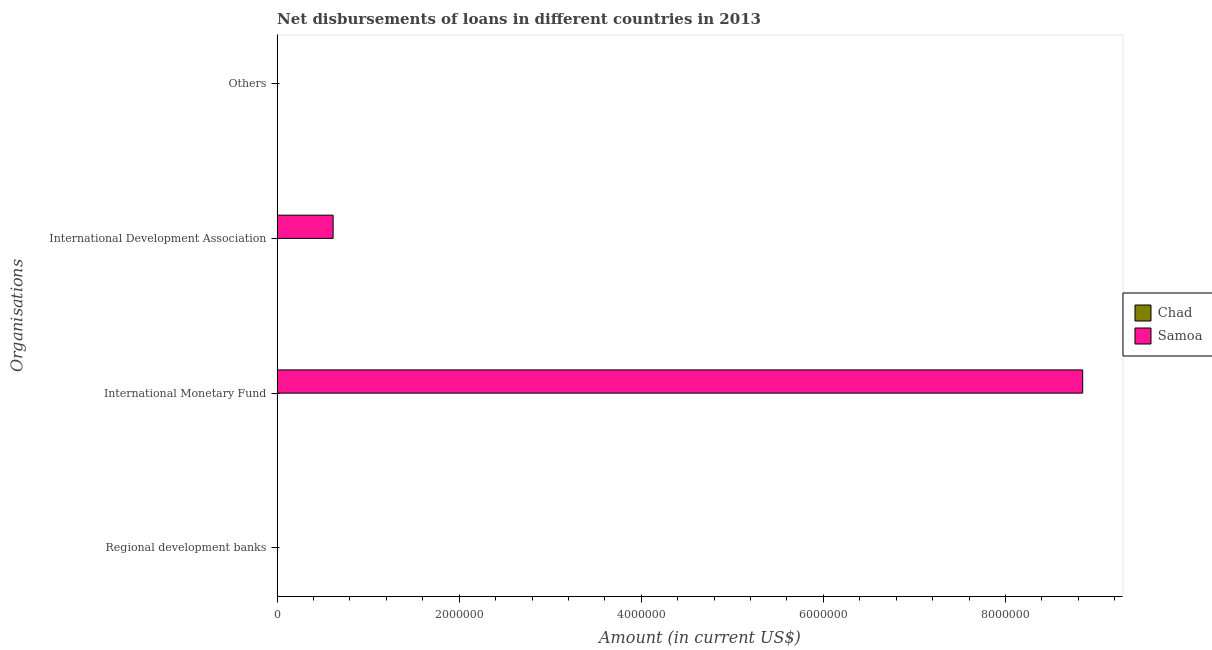How many different coloured bars are there?
Your answer should be compact. 1. Are the number of bars on each tick of the Y-axis equal?
Provide a short and direct response. No. What is the label of the 2nd group of bars from the top?
Keep it short and to the point. International Development Association. What is the amount of loan disimbursed by international monetary fund in Samoa?
Offer a very short reply. 8.85e+06. Across all countries, what is the maximum amount of loan disimbursed by international development association?
Give a very brief answer. 6.15e+05. In which country was the amount of loan disimbursed by international monetary fund maximum?
Keep it short and to the point. Samoa. What is the average amount of loan disimbursed by international monetary fund per country?
Keep it short and to the point. 4.42e+06. What is the difference between the highest and the lowest amount of loan disimbursed by international development association?
Your response must be concise. 6.15e+05. Is it the case that in every country, the sum of the amount of loan disimbursed by international monetary fund and amount of loan disimbursed by regional development banks is greater than the sum of amount of loan disimbursed by international development association and amount of loan disimbursed by other organisations?
Your response must be concise. No. Are all the bars in the graph horizontal?
Offer a very short reply. Yes. How many countries are there in the graph?
Offer a very short reply. 2. Are the values on the major ticks of X-axis written in scientific E-notation?
Provide a succinct answer. No. Does the graph contain any zero values?
Give a very brief answer. Yes. Does the graph contain grids?
Make the answer very short. No. How many legend labels are there?
Offer a very short reply. 2. How are the legend labels stacked?
Keep it short and to the point. Vertical. What is the title of the graph?
Provide a short and direct response. Net disbursements of loans in different countries in 2013. Does "Trinidad and Tobago" appear as one of the legend labels in the graph?
Give a very brief answer. No. What is the label or title of the X-axis?
Provide a succinct answer. Amount (in current US$). What is the label or title of the Y-axis?
Provide a succinct answer. Organisations. What is the Amount (in current US$) in Samoa in International Monetary Fund?
Your response must be concise. 8.85e+06. What is the Amount (in current US$) in Samoa in International Development Association?
Keep it short and to the point. 6.15e+05. What is the Amount (in current US$) in Chad in Others?
Your answer should be compact. 0. Across all Organisations, what is the maximum Amount (in current US$) of Samoa?
Your answer should be compact. 8.85e+06. What is the total Amount (in current US$) of Chad in the graph?
Give a very brief answer. 0. What is the total Amount (in current US$) of Samoa in the graph?
Your answer should be compact. 9.46e+06. What is the difference between the Amount (in current US$) in Samoa in International Monetary Fund and that in International Development Association?
Provide a short and direct response. 8.23e+06. What is the average Amount (in current US$) in Chad per Organisations?
Provide a short and direct response. 0. What is the average Amount (in current US$) in Samoa per Organisations?
Your answer should be compact. 2.37e+06. What is the ratio of the Amount (in current US$) of Samoa in International Monetary Fund to that in International Development Association?
Keep it short and to the point. 14.39. What is the difference between the highest and the lowest Amount (in current US$) of Samoa?
Provide a short and direct response. 8.85e+06. 